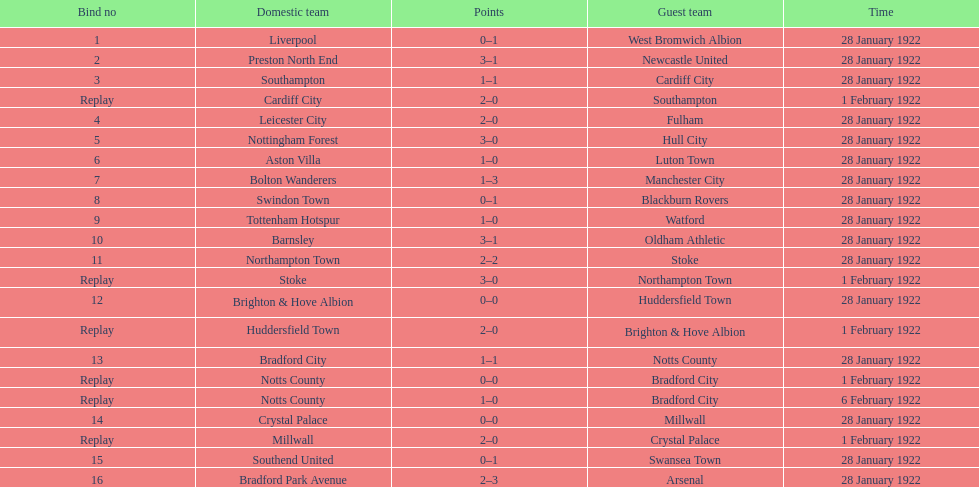What is the number of points scored on 6 february 1922? 1. 